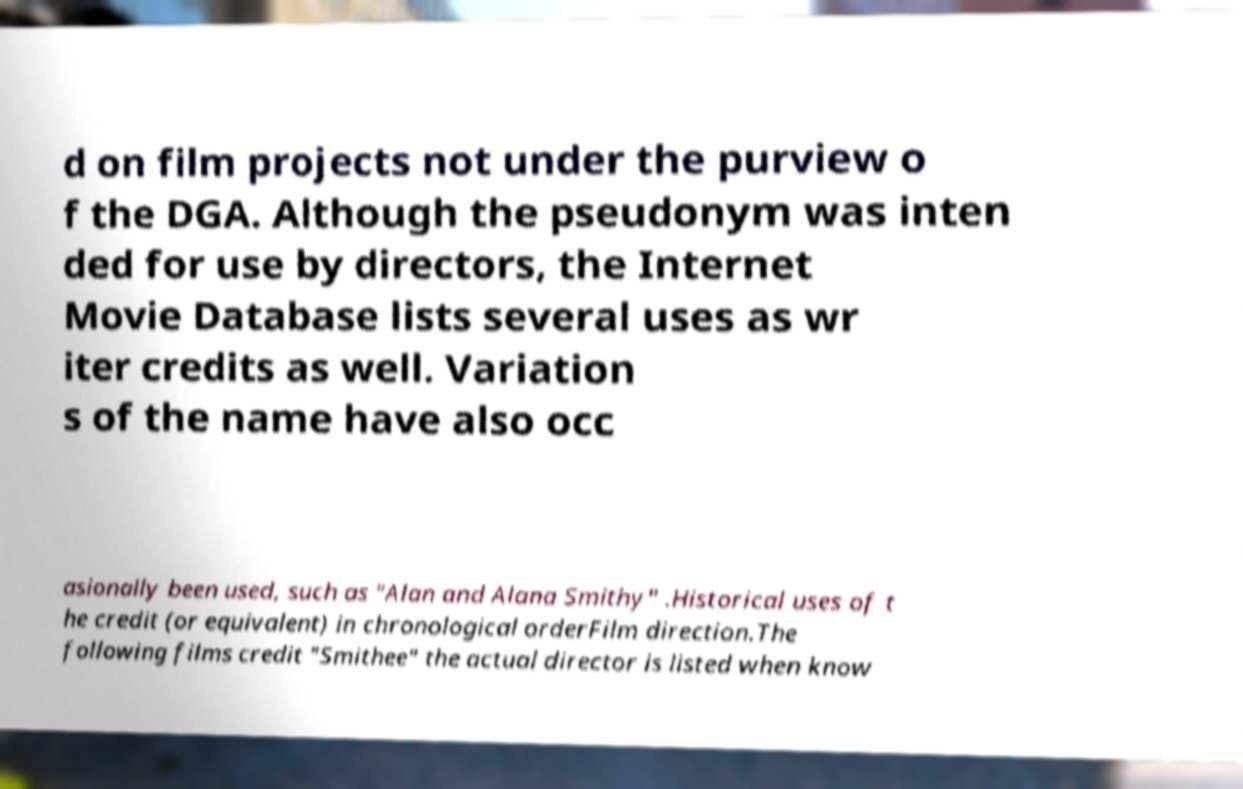Can you accurately transcribe the text from the provided image for me? d on film projects not under the purview o f the DGA. Although the pseudonym was inten ded for use by directors, the Internet Movie Database lists several uses as wr iter credits as well. Variation s of the name have also occ asionally been used, such as "Alan and Alana Smithy" .Historical uses of t he credit (or equivalent) in chronological orderFilm direction.The following films credit "Smithee" the actual director is listed when know 